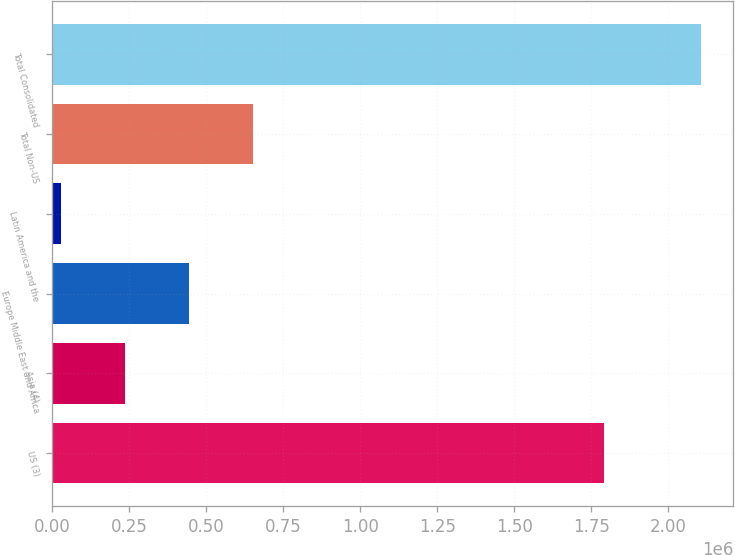Convert chart. <chart><loc_0><loc_0><loc_500><loc_500><bar_chart><fcel>US (3)<fcel>Asia (4)<fcel>Europe Middle East and Africa<fcel>Latin America and the<fcel>Total Non-US<fcel>Total Consolidated<nl><fcel>1.79272e+06<fcel>236954<fcel>444463<fcel>29445<fcel>651972<fcel>2.10453e+06<nl></chart> 